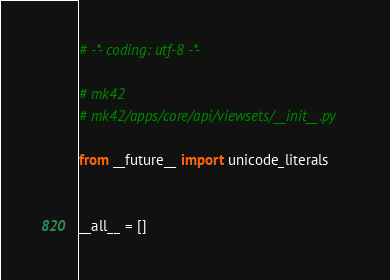Convert code to text. <code><loc_0><loc_0><loc_500><loc_500><_Python_># -*- coding: utf-8 -*-

# mk42
# mk42/apps/core/api/viewsets/__init__.py

from __future__ import unicode_literals


__all__ = []
</code> 